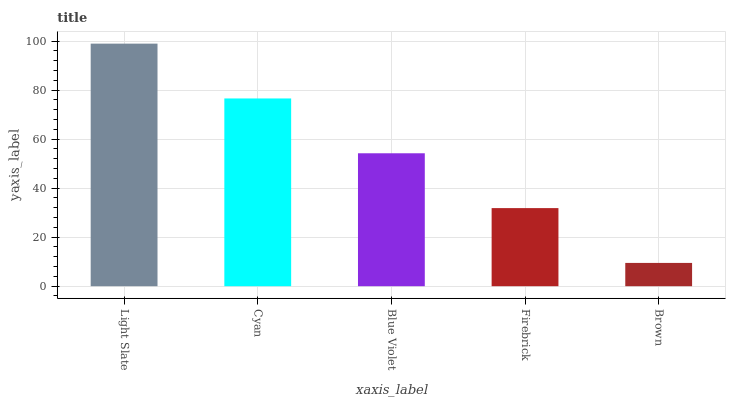Is Brown the minimum?
Answer yes or no. Yes. Is Light Slate the maximum?
Answer yes or no. Yes. Is Cyan the minimum?
Answer yes or no. No. Is Cyan the maximum?
Answer yes or no. No. Is Light Slate greater than Cyan?
Answer yes or no. Yes. Is Cyan less than Light Slate?
Answer yes or no. Yes. Is Cyan greater than Light Slate?
Answer yes or no. No. Is Light Slate less than Cyan?
Answer yes or no. No. Is Blue Violet the high median?
Answer yes or no. Yes. Is Blue Violet the low median?
Answer yes or no. Yes. Is Firebrick the high median?
Answer yes or no. No. Is Light Slate the low median?
Answer yes or no. No. 